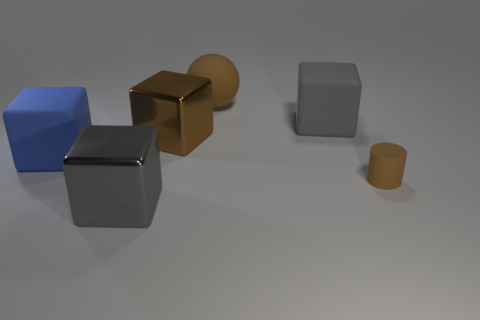Are there any patterns or textures visible on the surfaces in this scene? There are no distinct patterns or textures on the objects themselves; they all exhibit smooth surfaces. However, the floor has a subtle texture that is more evident where the light is brighter. 